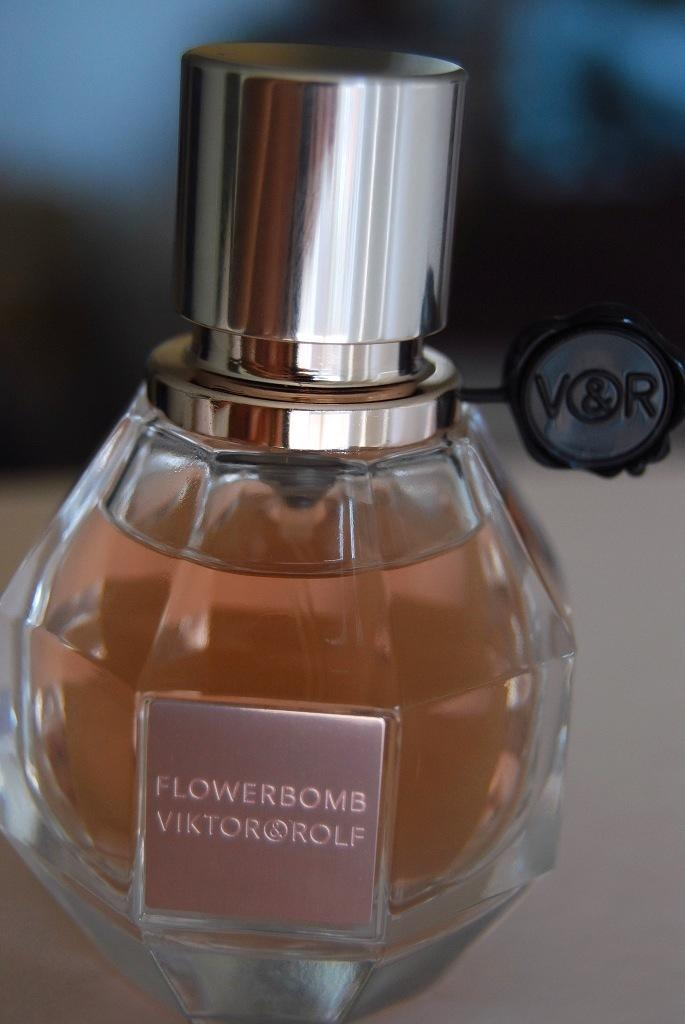<image>
Create a compact narrative representing the image presented. A bottle of perfume called Flowerbomb by Vikto & Rolf. 